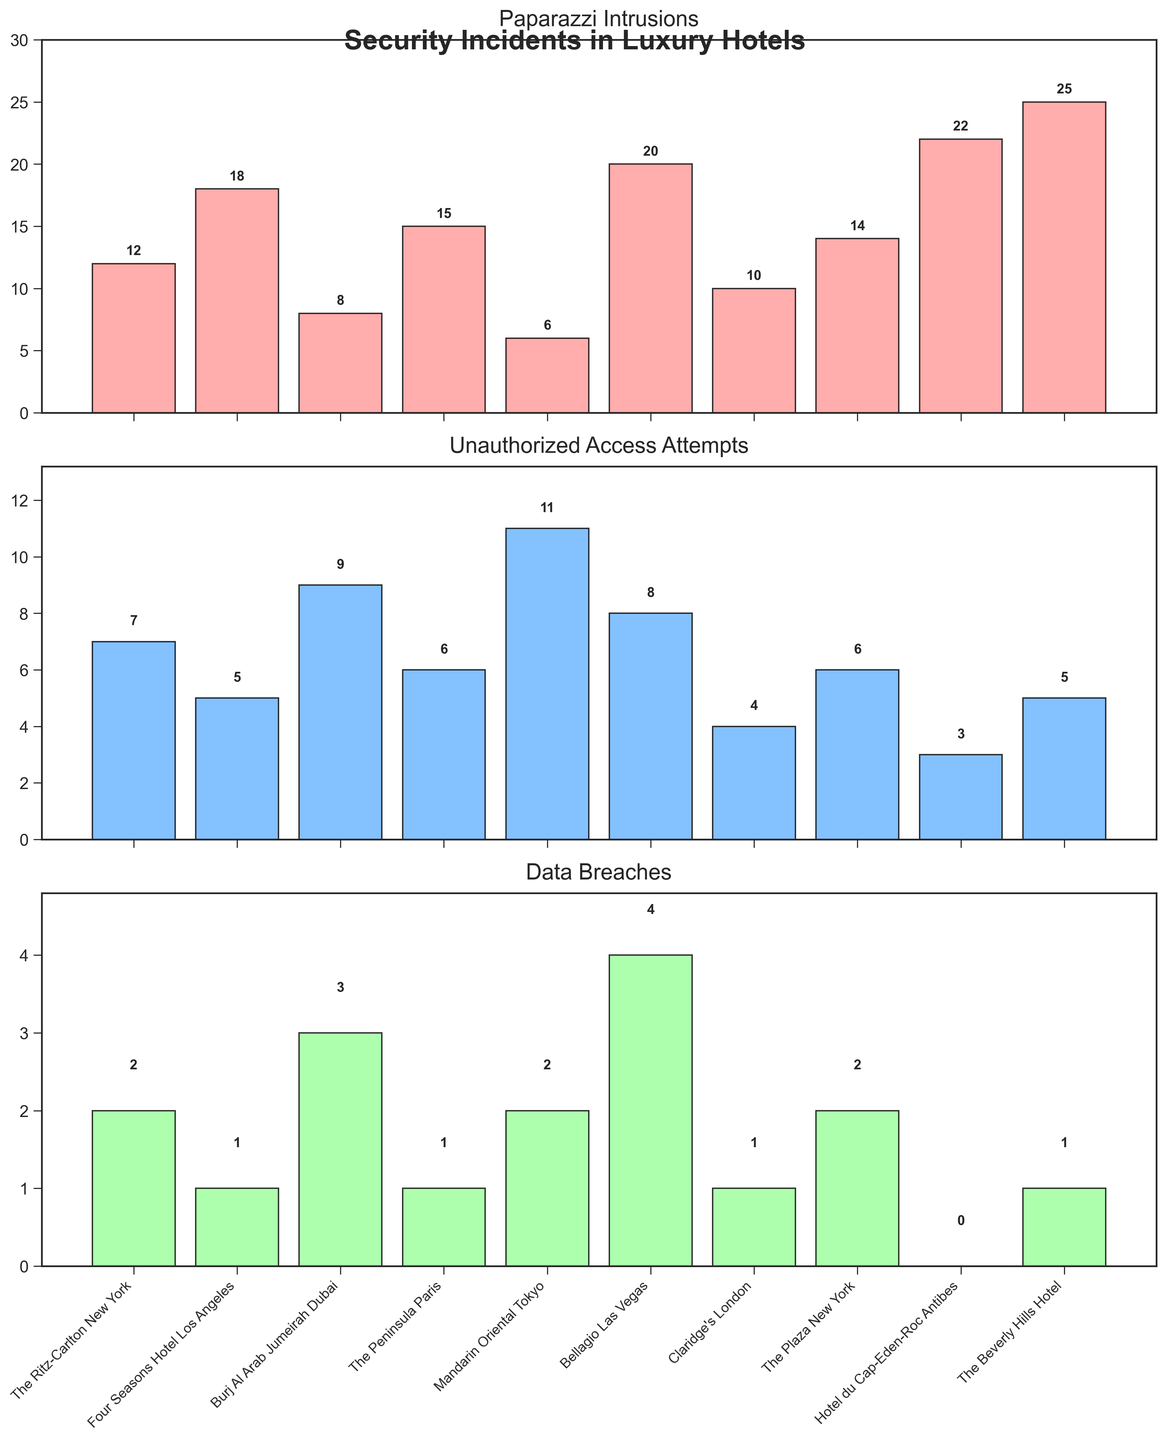Which hotel had the highest number of paparazzi intrusions? To find this, look at the bar heights in the "Paparazzi Intrusions" subplot. The Beverly Hills Hotel has the tallest bar with 25 paparazzi intrusions.
Answer: The Beverly Hills Hotel What is the total number of unauthorized access attempts across all hotels? Add the values of unauthorized access attempts for each hotel: 7 + 5 + 9 + 6 + 11 + 8 + 4 + 6 + 3 + 5 = 64.
Answer: 64 Which hotel had the fewest data breaches? Look at the bar heights in the "Data Breaches" subplot. Hotel du Cap-Eden-Roc Antibes has the shortest bar with 0 breaches.
Answer: Hotel du Cap-Eden-Roc Antibes How does the number of paparazzi intrusions at Bellagio Las Vegas compare to those at The Peninsula Paris? Bellagio Las Vegas had 20 paparazzi intrusions while The Peninsula Paris had 15. So, Bellagio Las Vegas had 5 more intrusions.
Answer: Bellagio Las Vegas had 5 more intrusions What is the average number of paparazzi intrusions among all hotels? To find the average, sum the values of paparazzi intrusions and divide by the number of hotels: (12+18+8+15+6+20+10+14+22+25)/10 = 150/10 = 15.
Answer: 15 Which hotel had equal numbers of unauthorized access attempts and data breaches? Compare the bars in both the "Unauthorized Access Attempts" and "Data Breaches" subplots. Claridge's London had 4 unauthorized access attempts and 1 data breach. The Peninsula Paris and The Plaza New York had 6 unauthorized access attempts and 1 data breach each.
Answer: Claridge's London How many more paparazzi intrusions did The Beverly Hills Hotel have compared to Mandarin Oriental Tokyo? The Beverly Hills Hotel had 25 paparazzi intrusions while Mandarin Oriental Tokyo had 6. The difference is 25 - 6 = 19.
Answer: 19 Which incident type had the highest occurrence at The Ritz-Carlton New York? Look at the bars for The Ritz-Carlton New York in all three subplots. Paparazzi intrusions had the highest occurrence with 12 incidents.
Answer: Paparazzi Intrusions What is the combined total of data breaches for all hotels? Sum the values of data breaches for each hotel: 2 + 1 + 3 + 1 + 2 + 4 + 1 + 2 + 0 + 1 = 17.
Answer: 17 Compare the highest number of incidents across all hotels for each type. Identify the highest bars in each subplot: Paparazzi Intrusions (The Beverly Hills Hotel, 25), Unauthorized Access Attempts (Mandarin Oriental Tokyo, 11), Data Breaches (Bellagio Las Vegas, 4).
Answer: Paparazzi Intrusions: 25, Unauthorized Access Attempts: 11, Data Breaches: 4 